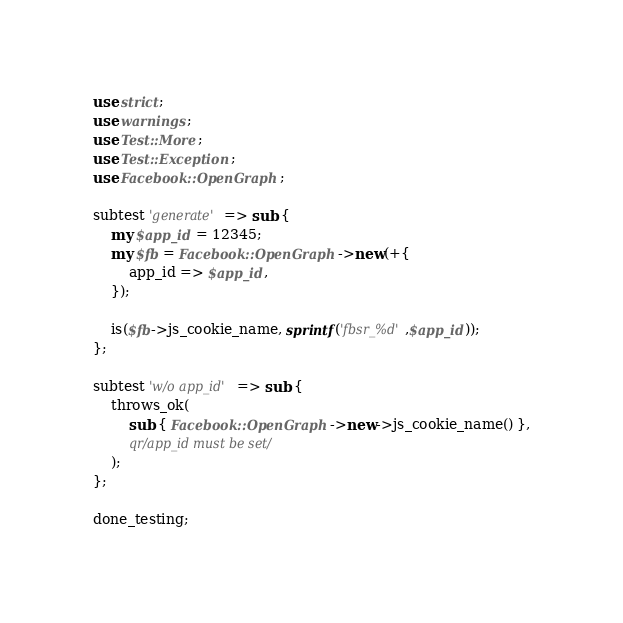Convert code to text. <code><loc_0><loc_0><loc_500><loc_500><_Perl_>use strict;
use warnings;
use Test::More;
use Test::Exception;
use Facebook::OpenGraph;

subtest 'generate' => sub {
    my $app_id = 12345;
    my $fb = Facebook::OpenGraph->new(+{
        app_id => $app_id,
    });

    is($fb->js_cookie_name, sprintf('fbsr_%d',$app_id));
};

subtest 'w/o app_id' => sub {
    throws_ok(
        sub { Facebook::OpenGraph->new->js_cookie_name() },
        qr/app_id must be set/
    );
};

done_testing;
</code> 